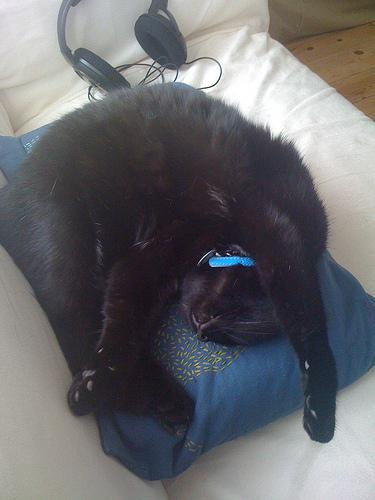Question: where is the cat laying?
Choices:
A. On a bed.
B. On a couch.
C. A pillow.
D. In a basket.
Answer with the letter. Answer: C Question: what color is the pillow?
Choices:
A. White.
B. Grey.
C. Blue.
D. Black.
Answer with the letter. Answer: C Question: how is the cat's head positioned?
Choices:
A. Tilted to the side.
B. Upside down.
C. Straight up and down.
D. It's neck is broken.
Answer with the letter. Answer: B Question: what color are the beads on the pillow?
Choices:
A. Gold.
B. Orange.
C. Red.
D. White.
Answer with the letter. Answer: A 